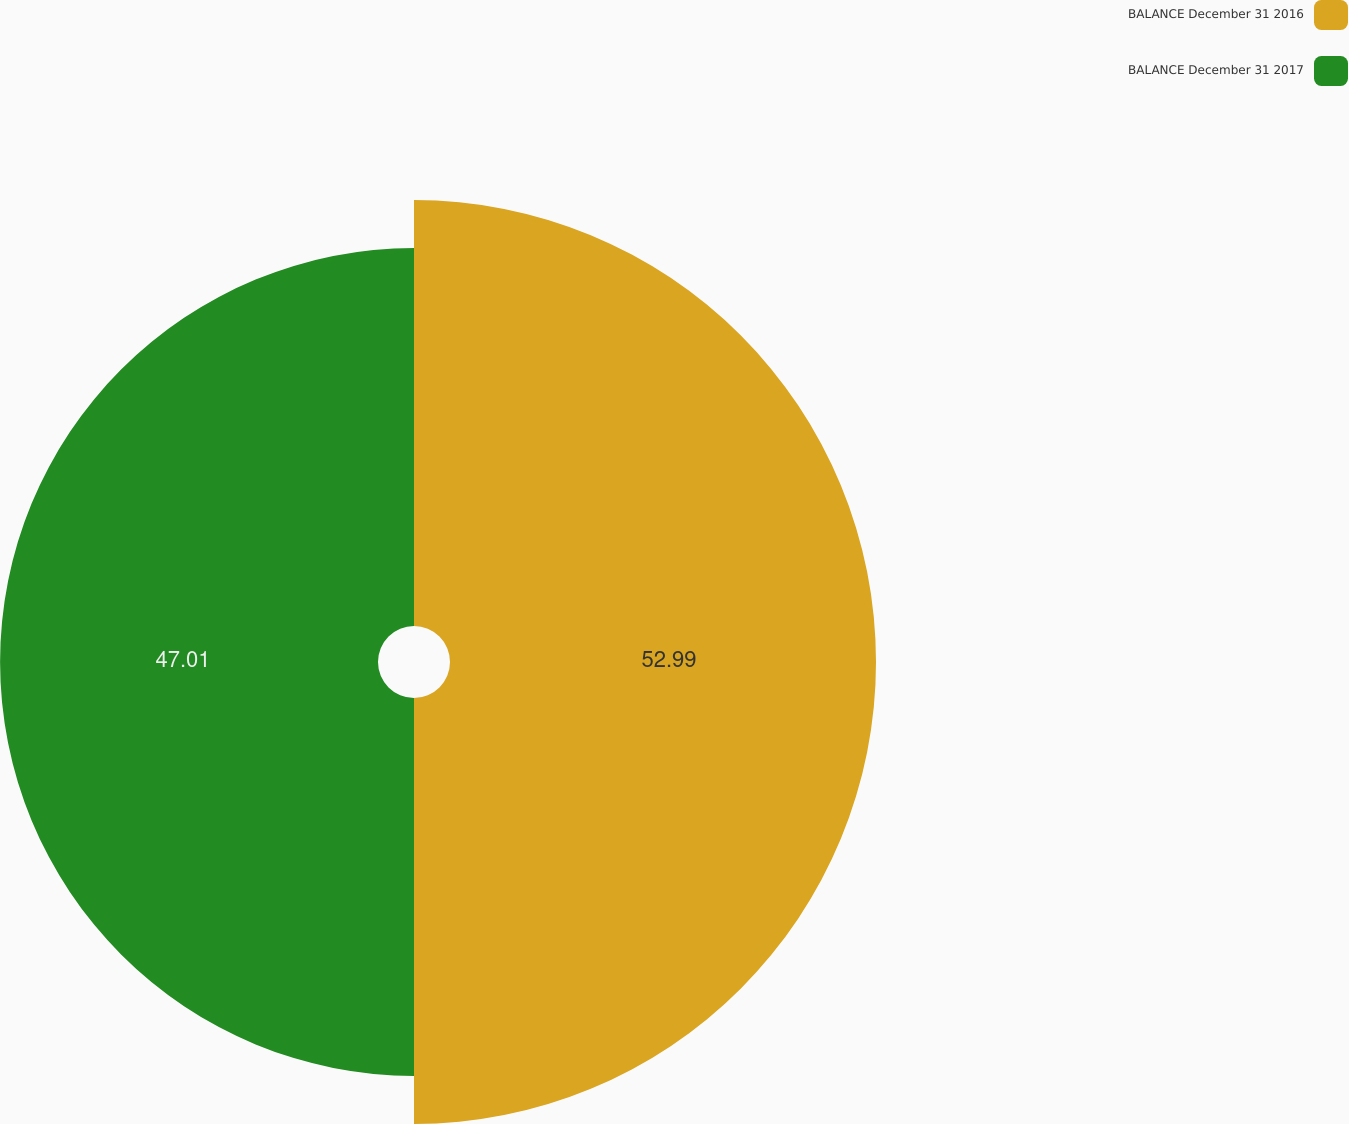Convert chart to OTSL. <chart><loc_0><loc_0><loc_500><loc_500><pie_chart><fcel>BALANCE December 31 2016<fcel>BALANCE December 31 2017<nl><fcel>52.99%<fcel>47.01%<nl></chart> 